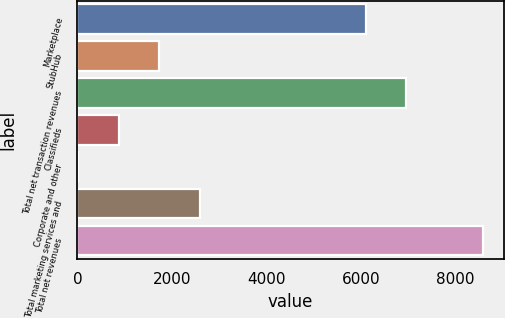<chart> <loc_0><loc_0><loc_500><loc_500><bar_chart><fcel>Marketplace<fcel>StubHub<fcel>Total net transaction revenues<fcel>Classifieds<fcel>Corporate and other<fcel>Total marketing services and<fcel>Total net revenues<nl><fcel>6103<fcel>1732<fcel>6960.5<fcel>874.5<fcel>17<fcel>2589.5<fcel>8592<nl></chart> 